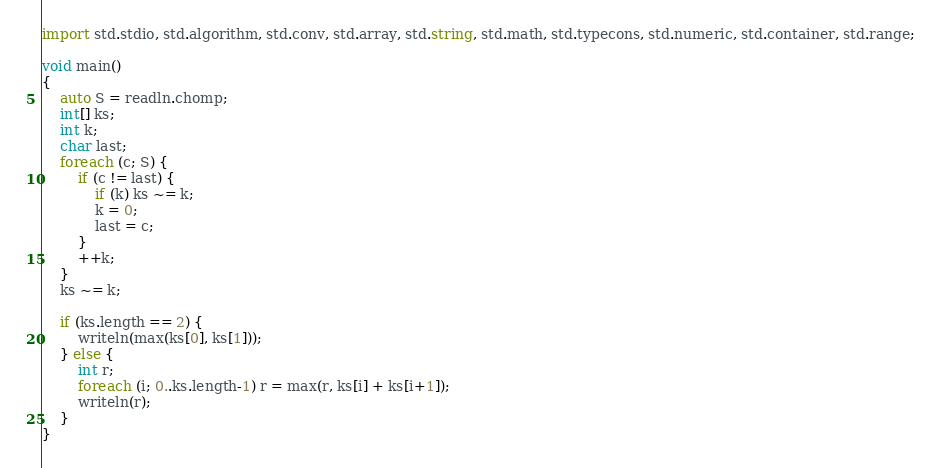<code> <loc_0><loc_0><loc_500><loc_500><_D_>import std.stdio, std.algorithm, std.conv, std.array, std.string, std.math, std.typecons, std.numeric, std.container, std.range;

void main()
{
    auto S = readln.chomp;
    int[] ks;
    int k;
    char last;
    foreach (c; S) {
        if (c != last) {
            if (k) ks ~= k;
            k = 0;
            last = c;
        }
        ++k;
    }
    ks ~= k;

    if (ks.length == 2) {
        writeln(max(ks[0], ks[1]));
    } else {
        int r;
        foreach (i; 0..ks.length-1) r = max(r, ks[i] + ks[i+1]);
        writeln(r);
    }
}</code> 